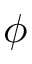<formula> <loc_0><loc_0><loc_500><loc_500>\phi</formula> 